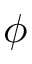<formula> <loc_0><loc_0><loc_500><loc_500>\phi</formula> 